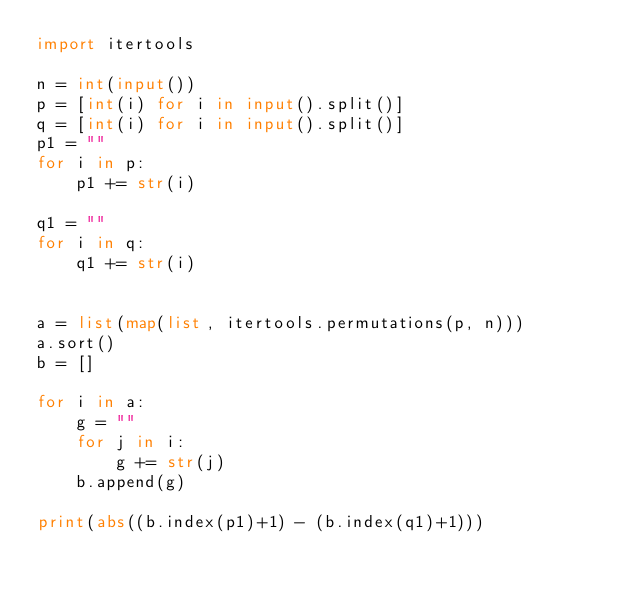Convert code to text. <code><loc_0><loc_0><loc_500><loc_500><_Python_>import itertools

n = int(input())
p = [int(i) for i in input().split()]
q = [int(i) for i in input().split()]
p1 = ""
for i in p:
    p1 += str(i)

q1 = ""
for i in q:
    q1 += str(i)


a = list(map(list, itertools.permutations(p, n)))
a.sort()
b = []

for i in a:
    g = ""
    for j in i:
        g += str(j)
    b.append(g)

print(abs((b.index(p1)+1) - (b.index(q1)+1)))

</code> 